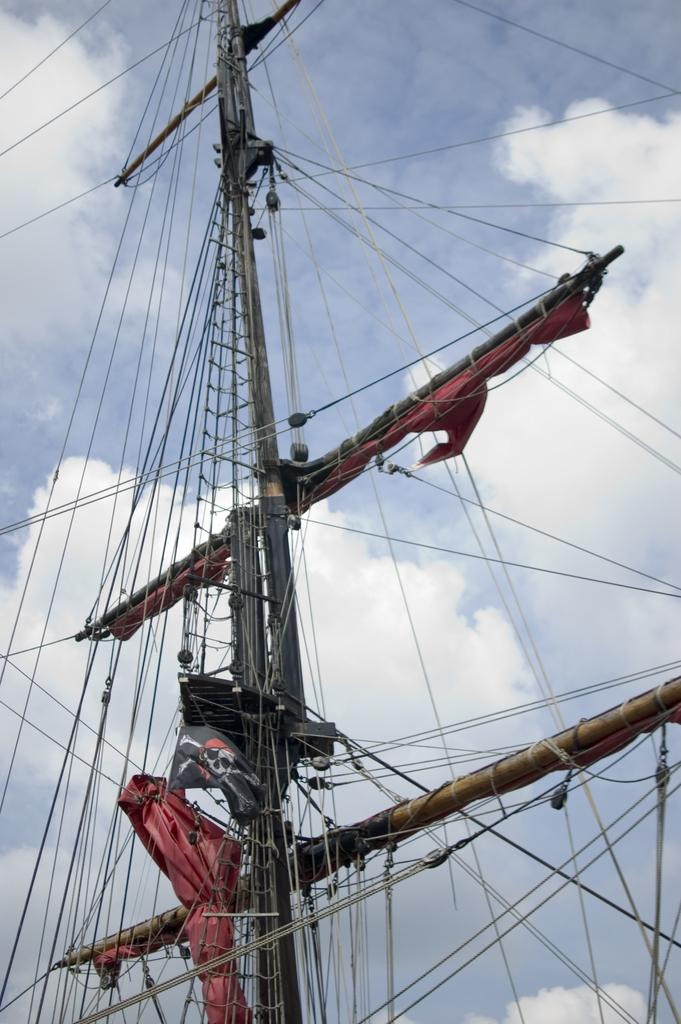What is the main structure in the picture? There is a bridge in the picture. What feature can be seen on the bridge? The bridge has ropes attached. What is the condition of the sky in the picture? The sky is clear in the picture. How many snails can be seen crawling on the secretary in the image? There is no secretary or snails present in the image; it features a bridge with ropes. 